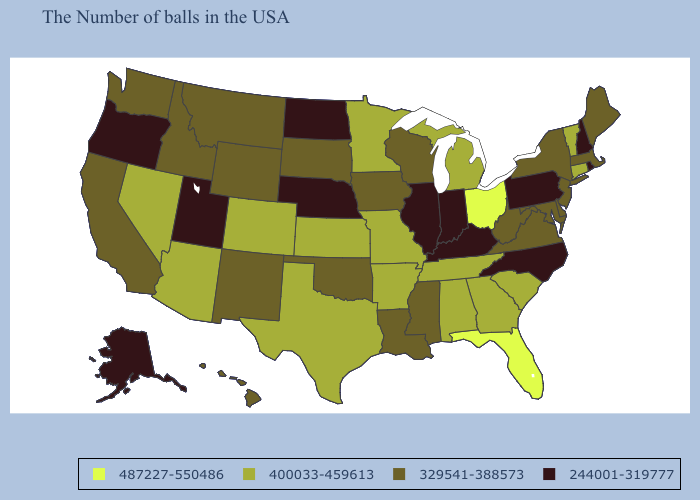Among the states that border California , which have the highest value?
Be succinct. Arizona, Nevada. Name the states that have a value in the range 329541-388573?
Short answer required. Maine, Massachusetts, New York, New Jersey, Delaware, Maryland, Virginia, West Virginia, Wisconsin, Mississippi, Louisiana, Iowa, Oklahoma, South Dakota, Wyoming, New Mexico, Montana, Idaho, California, Washington, Hawaii. Does Ohio have the highest value in the USA?
Short answer required. Yes. Name the states that have a value in the range 400033-459613?
Answer briefly. Vermont, Connecticut, South Carolina, Georgia, Michigan, Alabama, Tennessee, Missouri, Arkansas, Minnesota, Kansas, Texas, Colorado, Arizona, Nevada. Does the map have missing data?
Give a very brief answer. No. Does Wyoming have a higher value than Nevada?
Keep it brief. No. Does Missouri have a lower value than Arizona?
Write a very short answer. No. What is the highest value in the MidWest ?
Keep it brief. 487227-550486. Name the states that have a value in the range 329541-388573?
Answer briefly. Maine, Massachusetts, New York, New Jersey, Delaware, Maryland, Virginia, West Virginia, Wisconsin, Mississippi, Louisiana, Iowa, Oklahoma, South Dakota, Wyoming, New Mexico, Montana, Idaho, California, Washington, Hawaii. Which states hav the highest value in the Northeast?
Quick response, please. Vermont, Connecticut. Name the states that have a value in the range 329541-388573?
Short answer required. Maine, Massachusetts, New York, New Jersey, Delaware, Maryland, Virginia, West Virginia, Wisconsin, Mississippi, Louisiana, Iowa, Oklahoma, South Dakota, Wyoming, New Mexico, Montana, Idaho, California, Washington, Hawaii. What is the highest value in the USA?
Keep it brief. 487227-550486. How many symbols are there in the legend?
Concise answer only. 4. Does Missouri have the lowest value in the USA?
Answer briefly. No. Does the first symbol in the legend represent the smallest category?
Keep it brief. No. 